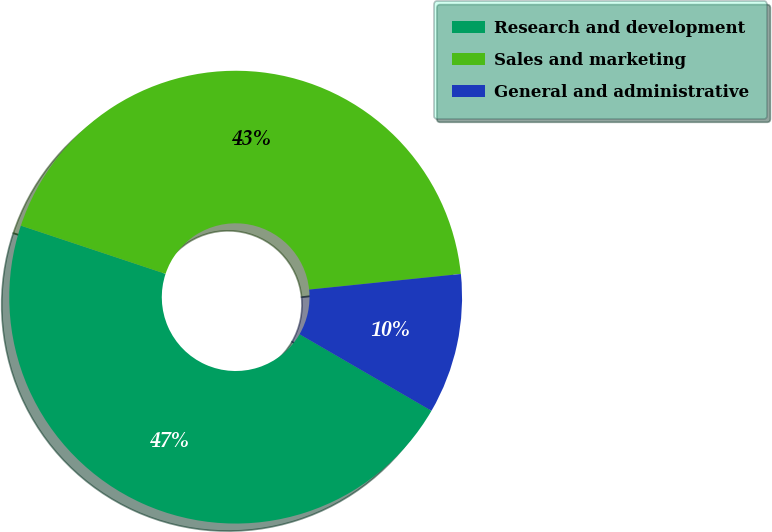Convert chart to OTSL. <chart><loc_0><loc_0><loc_500><loc_500><pie_chart><fcel>Research and development<fcel>Sales and marketing<fcel>General and administrative<nl><fcel>46.75%<fcel>43.25%<fcel>10.0%<nl></chart> 